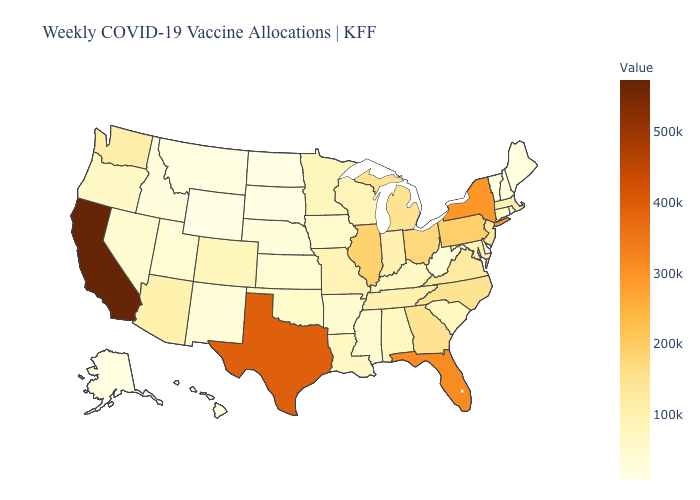Among the states that border Alabama , which have the highest value?
Short answer required. Florida. Does Maine have the lowest value in the Northeast?
Give a very brief answer. No. Among the states that border Illinois , which have the highest value?
Quick response, please. Indiana. Does Delaware have the lowest value in the South?
Quick response, please. Yes. Among the states that border Kentucky , does Illinois have the highest value?
Answer briefly. Yes. 